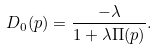<formula> <loc_0><loc_0><loc_500><loc_500>D _ { 0 } ( p ) = \frac { - \lambda } { 1 + \lambda \Pi ( p ) } .</formula> 